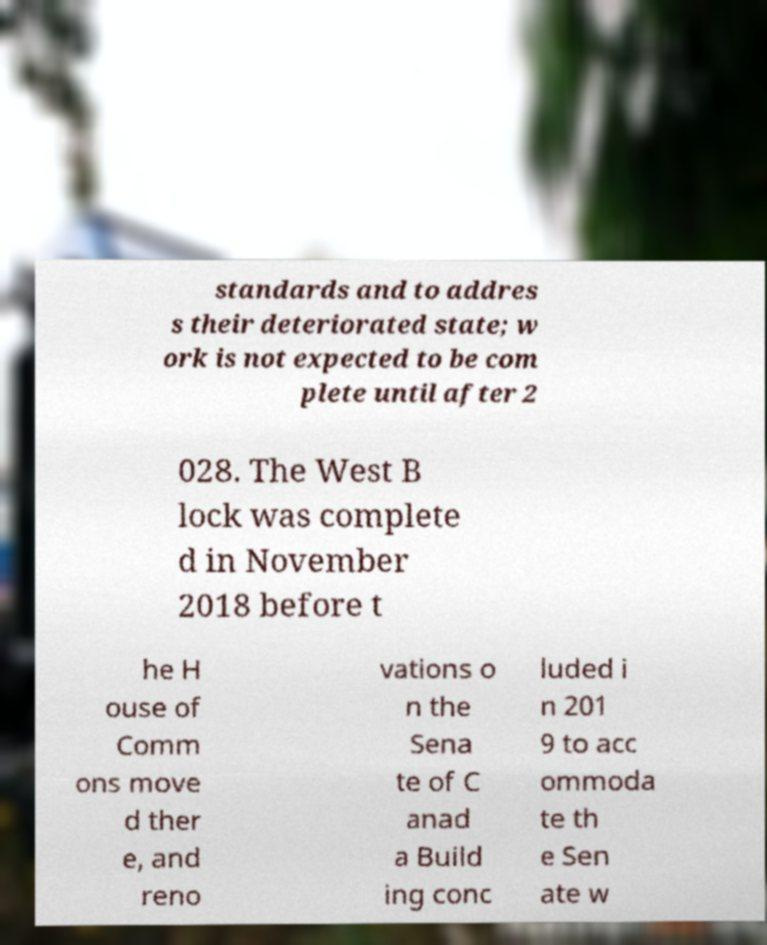What messages or text are displayed in this image? I need them in a readable, typed format. standards and to addres s their deteriorated state; w ork is not expected to be com plete until after 2 028. The West B lock was complete d in November 2018 before t he H ouse of Comm ons move d ther e, and reno vations o n the Sena te of C anad a Build ing conc luded i n 201 9 to acc ommoda te th e Sen ate w 